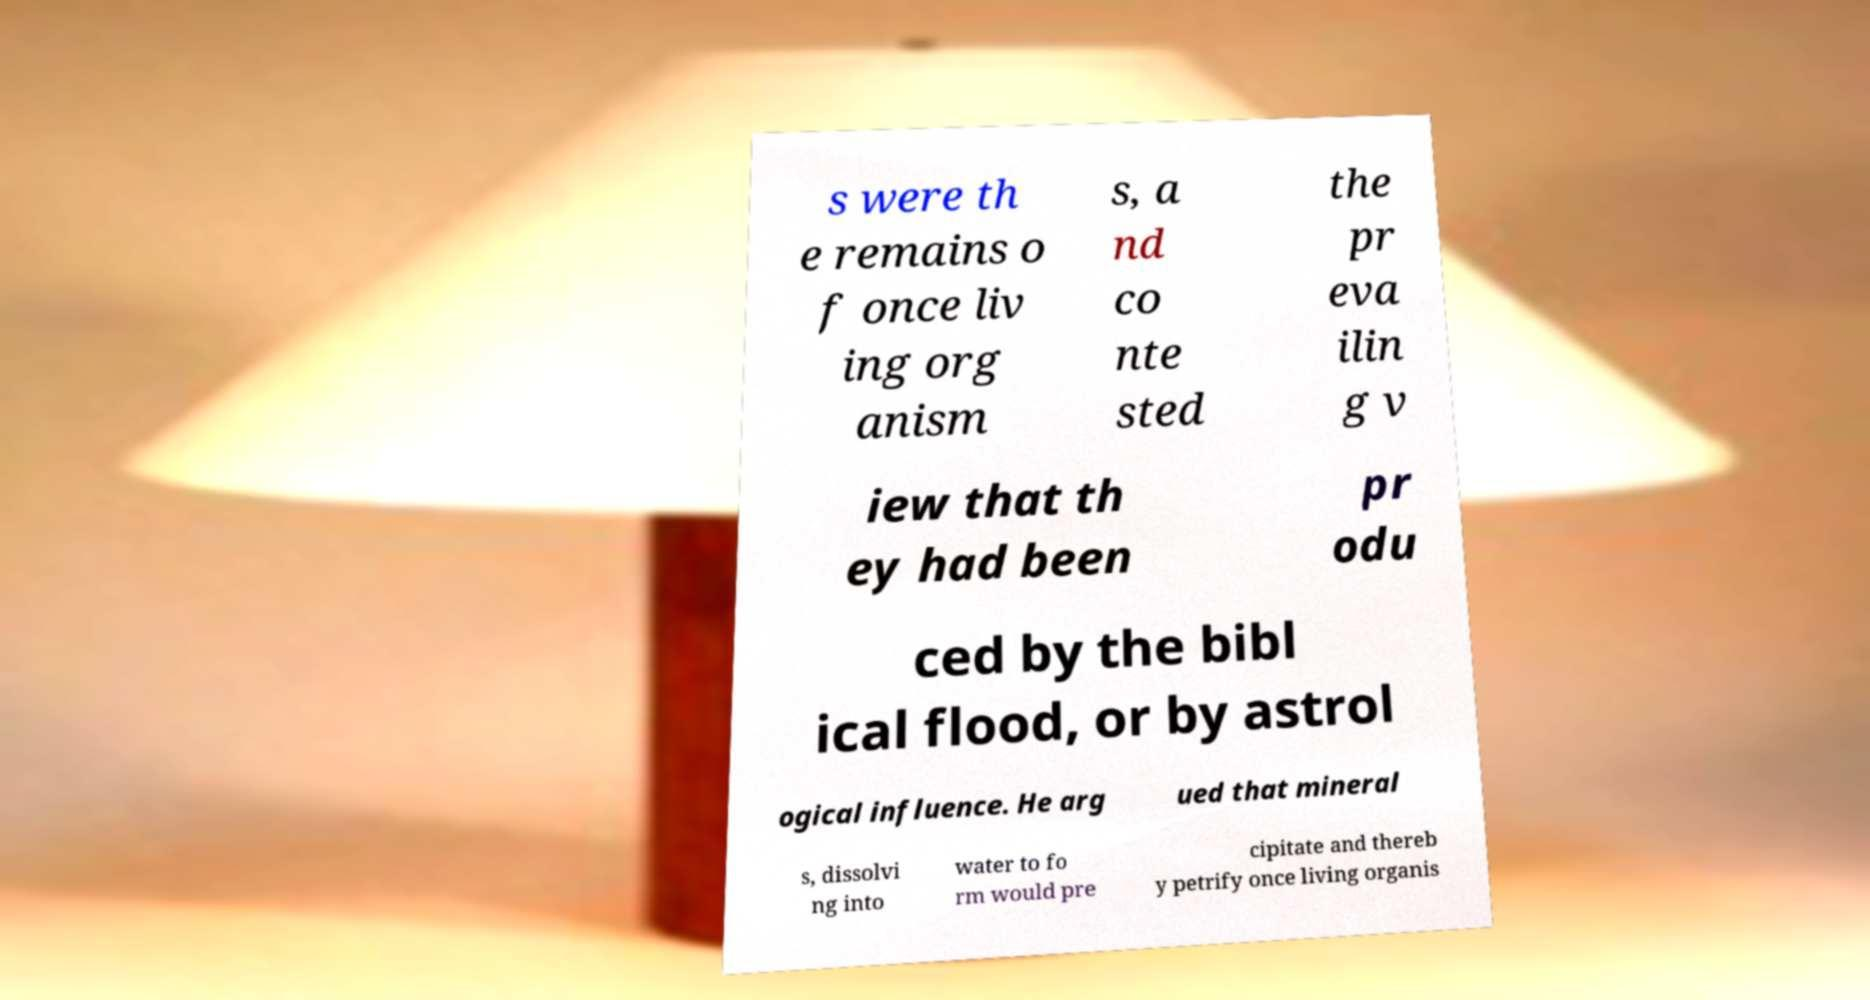What messages or text are displayed in this image? I need them in a readable, typed format. s were th e remains o f once liv ing org anism s, a nd co nte sted the pr eva ilin g v iew that th ey had been pr odu ced by the bibl ical flood, or by astrol ogical influence. He arg ued that mineral s, dissolvi ng into water to fo rm would pre cipitate and thereb y petrify once living organis 